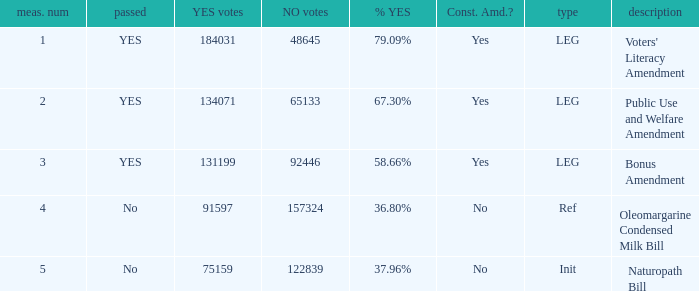What is the measure number for the init type?  5.0. 